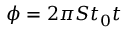Convert formula to latex. <formula><loc_0><loc_0><loc_500><loc_500>\phi = 2 \pi S t _ { 0 } t</formula> 